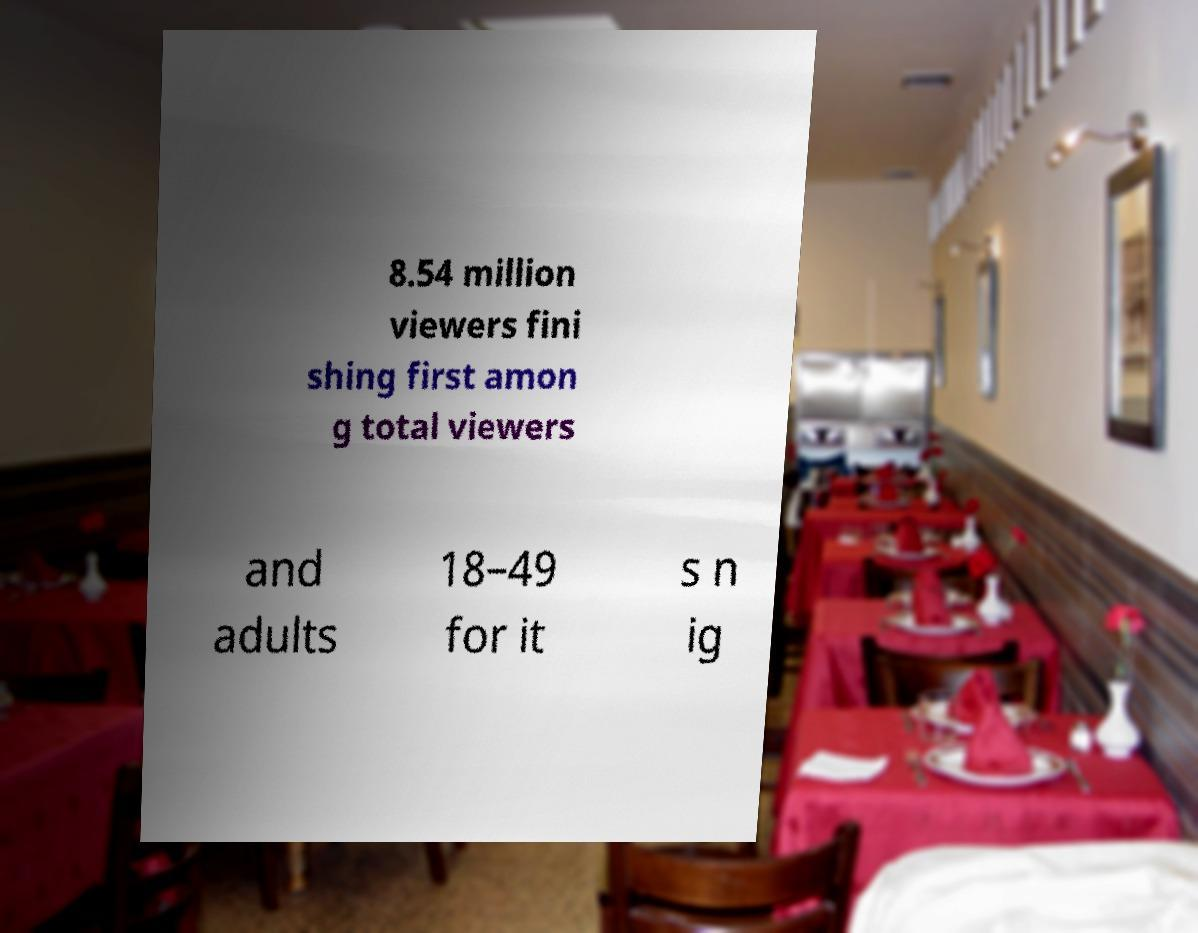For documentation purposes, I need the text within this image transcribed. Could you provide that? 8.54 million viewers fini shing first amon g total viewers and adults 18–49 for it s n ig 